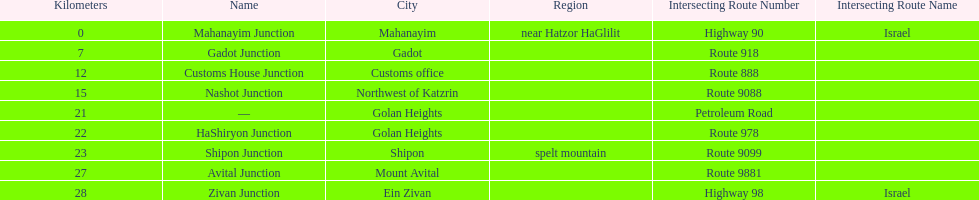What is the total kilometers that separates the mahanayim junction and the shipon junction? 23. 